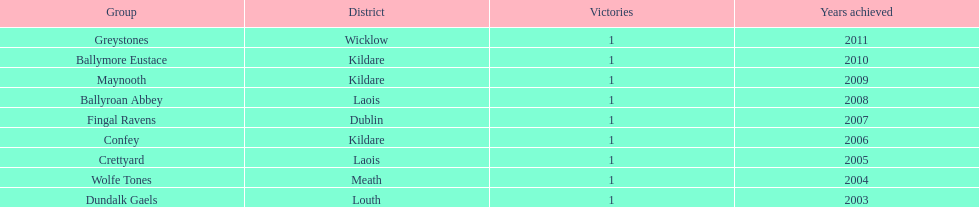Which team was the previous winner before ballyroan abbey in 2008? Fingal Ravens. 